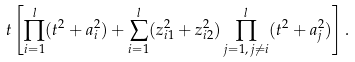Convert formula to latex. <formula><loc_0><loc_0><loc_500><loc_500>t \left [ \prod _ { i = 1 } ^ { l } ( t ^ { 2 } + a _ { i } ^ { 2 } ) + \sum _ { i = 1 } ^ { l } ( z _ { i 1 } ^ { 2 } + z _ { i 2 } ^ { 2 } ) \prod _ { j = 1 , \, j \neq i } ^ { l } ( t ^ { 2 } + a _ { j } ^ { 2 } ) \right ] .</formula> 